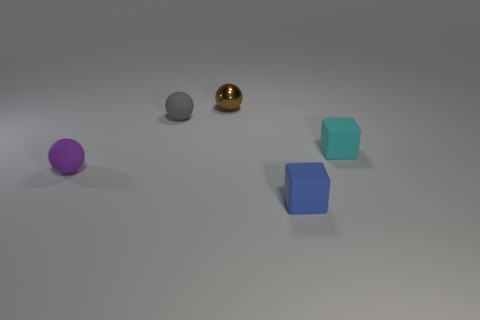How many brown metallic blocks are the same size as the gray ball?
Your response must be concise. 0. Is the size of the sphere that is in front of the gray object the same as the brown thing?
Your answer should be compact. Yes. The small rubber object that is both in front of the cyan rubber thing and behind the blue rubber block has what shape?
Offer a terse response. Sphere. Are there any blocks behind the cyan rubber thing?
Make the answer very short. No. Is the shape of the small purple thing the same as the cyan object?
Your answer should be compact. No. Are there the same number of tiny blocks behind the blue matte block and small gray matte things that are in front of the small brown object?
Your answer should be very brief. Yes. What number of other things are the same material as the small gray ball?
Give a very brief answer. 3. What number of large things are balls or gray things?
Offer a terse response. 0. Are there the same number of rubber things that are to the left of the small purple ball and small cyan cubes?
Provide a succinct answer. No. Is there a tiny rubber object to the left of the small block that is in front of the small cyan block?
Provide a succinct answer. Yes. 